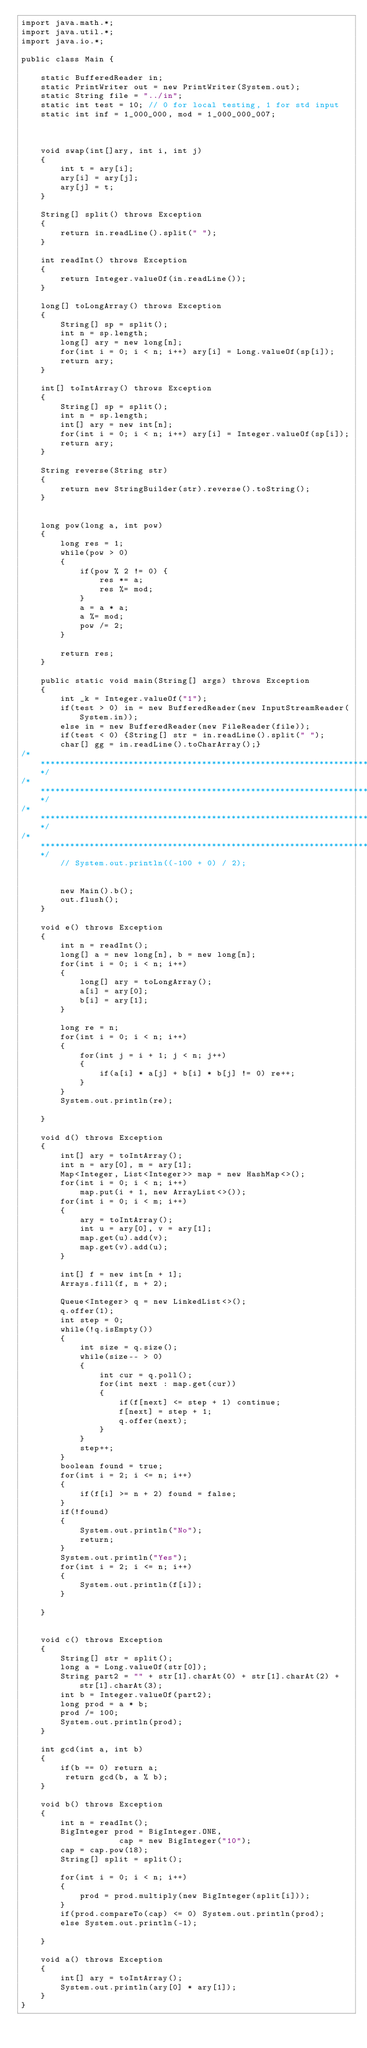<code> <loc_0><loc_0><loc_500><loc_500><_Java_>import java.math.*;
import java.util.*;
import java.io.*;
  
public class Main { 
  
    static BufferedReader in;
    static PrintWriter out = new PrintWriter(System.out);
    static String file = "../in";
    static int test = 10; // 0 for local testing, 1 for std input
    static int inf = 1_000_000, mod = 1_000_000_007;



    void swap(int[]ary, int i, int j)
    {
        int t = ary[i];
        ary[i] = ary[j];
        ary[j] = t;
    }
    
    String[] split() throws Exception
    {
        return in.readLine().split(" ");
    }

    int readInt() throws Exception
    {
        return Integer.valueOf(in.readLine());
    }

    long[] toLongArray() throws Exception
    {
        String[] sp = split();
        int n = sp.length;
        long[] ary = new long[n];
        for(int i = 0; i < n; i++) ary[i] = Long.valueOf(sp[i]);
        return ary;
    }

    int[] toIntArray() throws Exception
    {
        String[] sp = split();
        int n = sp.length;
        int[] ary = new int[n];
        for(int i = 0; i < n; i++) ary[i] = Integer.valueOf(sp[i]);
        return ary;
    }

    String reverse(String str)
    {
        return new StringBuilder(str).reverse().toString();
    }


    long pow(long a, int pow)
    {
        long res = 1;
        while(pow > 0)
        {
            if(pow % 2 != 0) {
                res *= a;
                res %= mod;
            }
            a = a * a;
            a %= mod;
            pow /= 2;
        }

        return res;
    }

    public static void main(String[] args) throws Exception
    {
        int _k = Integer.valueOf("1");
        if(test > 0) in = new BufferedReader(new InputStreamReader(System.in));
        else in = new BufferedReader(new FileReader(file));
        if(test < 0) {String[] str = in.readLine().split(" ");
        char[] gg = in.readLine().toCharArray();}
/***********************************************************************/
/***********************************************************************/
/***********************************************************************/
/***********************************************************************/
        // System.out.println((-100 + 0) / 2);

        
        new Main().b();
        out.flush();
    }

    void e() throws Exception
    {
        int n = readInt();
        long[] a = new long[n], b = new long[n];
        for(int i = 0; i < n; i++)
        {
            long[] ary = toLongArray();    
            a[i] = ary[0];
            b[i] = ary[1];
        }
        
        long re = n;
        for(int i = 0; i < n; i++)
        {
            for(int j = i + 1; j < n; j++)
            {
                if(a[i] * a[j] + b[i] * b[j] != 0) re++;
            }
        }
        System.out.println(re);
        
    }

    void d() throws Exception
    {
        int[] ary = toIntArray();
        int n = ary[0], m = ary[1];
        Map<Integer, List<Integer>> map = new HashMap<>();
        for(int i = 0; i < n; i++)
            map.put(i + 1, new ArrayList<>());
        for(int i = 0; i < m; i++)
        {
            ary = toIntArray();
            int u = ary[0], v = ary[1];
            map.get(u).add(v);
            map.get(v).add(u);
        }

        int[] f = new int[n + 1];
        Arrays.fill(f, n + 2);

        Queue<Integer> q = new LinkedList<>();
        q.offer(1);
        int step = 0;
        while(!q.isEmpty())
        {
            int size = q.size();
            while(size-- > 0)
            {
                int cur = q.poll();
                for(int next : map.get(cur))
                {
                    if(f[next] <= step + 1) continue;
                    f[next] = step + 1;
                    q.offer(next);
                }
            }
            step++;
        }
        boolean found = true;
        for(int i = 2; i <= n; i++)
        {
            if(f[i] >= n + 2) found = false;
        }
        if(!found) 
        {
            System.out.println("No");
            return;
        }
        System.out.println("Yes");
        for(int i = 2; i <= n; i++)
        {
            System.out.println(f[i]);
        }
        
    }


    void c() throws Exception
    {
        String[] str = split();
        long a = Long.valueOf(str[0]);
        String part2 = "" + str[1].charAt(0) + str[1].charAt(2) + str[1].charAt(3);
        int b = Integer.valueOf(part2);
        long prod = a * b;
        prod /= 100;
        System.out.println(prod);
    }

    int gcd(int a, int b)
    {
        if(b == 0) return a;
         return gcd(b, a % b);
    }

    void b() throws Exception
    {
        int n = readInt();
        BigInteger prod = BigInteger.ONE,
                    cap = new BigInteger("10");
        cap = cap.pow(18);
        String[] split = split();
        
        for(int i = 0; i < n; i++)
        {
            prod = prod.multiply(new BigInteger(split[i]));
        }    
        if(prod.compareTo(cap) <= 0) System.out.println(prod);
        else System.out.println(-1);
        
    }

    void a() throws Exception
    {
        int[] ary = toIntArray();
        System.out.println(ary[0] * ary[1]);
    }
}</code> 